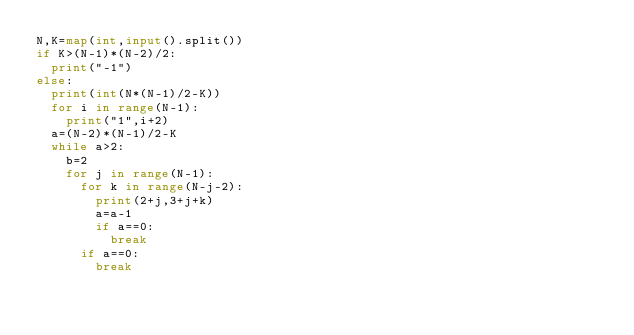Convert code to text. <code><loc_0><loc_0><loc_500><loc_500><_Python_>N,K=map(int,input().split())
if K>(N-1)*(N-2)/2:
  print("-1")
else:
  print(int(N*(N-1)/2-K))
  for i in range(N-1):
    print("1",i+2)
  a=(N-2)*(N-1)/2-K
  while a>2:
    b=2
    for j in range(N-1):
      for k in range(N-j-2):
        print(2+j,3+j+k)
        a=a-1
        if a==0:
          break
      if a==0:
        break
 </code> 